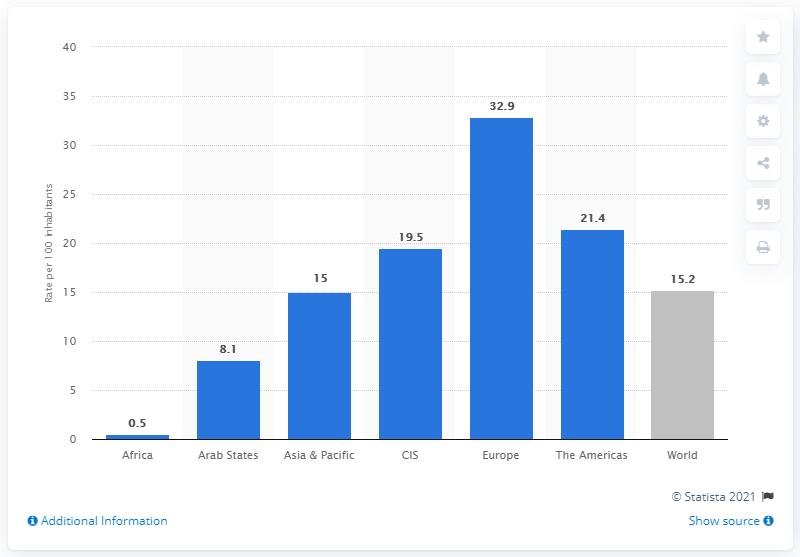Identify some key points in this picture. In 2020, there were 15.2 active fixed broadband subscriptions per 100 inhabitants of the global population. In 2020, the number of wired broadband subscriptions in Europe was 32.9%. 